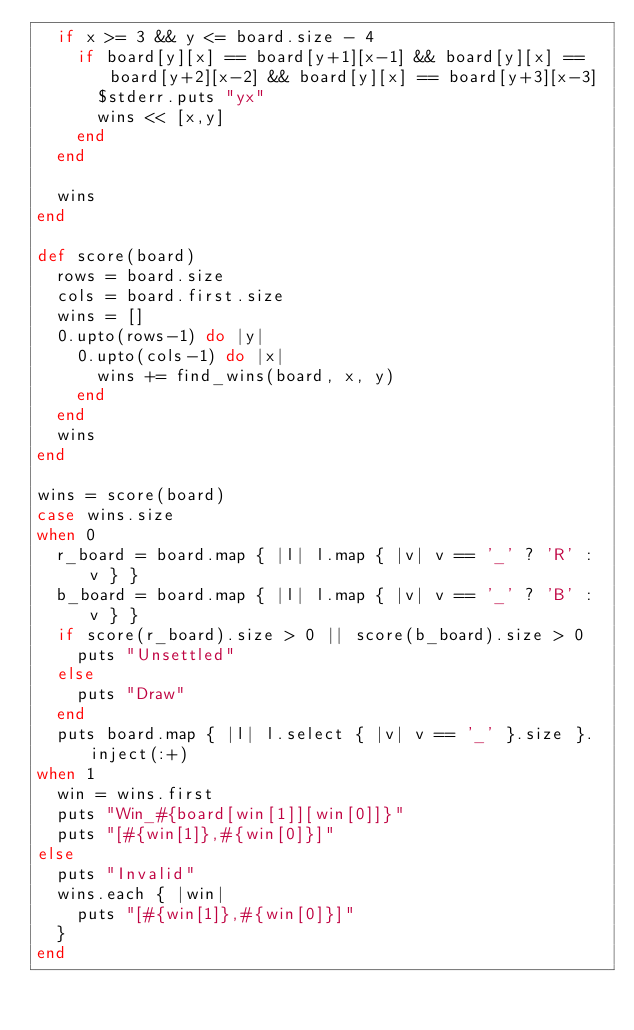Convert code to text. <code><loc_0><loc_0><loc_500><loc_500><_Ruby_>  if x >= 3 && y <= board.size - 4
    if board[y][x] == board[y+1][x-1] && board[y][x] == board[y+2][x-2] && board[y][x] == board[y+3][x-3]
      $stderr.puts "yx"
      wins << [x,y]
    end
  end
  
  wins
end

def score(board)
  rows = board.size
  cols = board.first.size
  wins = []
  0.upto(rows-1) do |y|
    0.upto(cols-1) do |x|
      wins += find_wins(board, x, y)
    end
  end
  wins
end

wins = score(board)
case wins.size
when 0
  r_board = board.map { |l| l.map { |v| v == '_' ? 'R' : v } }
  b_board = board.map { |l| l.map { |v| v == '_' ? 'B' : v } }
  if score(r_board).size > 0 || score(b_board).size > 0
    puts "Unsettled"
  else
    puts "Draw"
  end
  puts board.map { |l| l.select { |v| v == '_' }.size }.inject(:+)
when 1
  win = wins.first
  puts "Win_#{board[win[1]][win[0]]}"
  puts "[#{win[1]},#{win[0]}]"
else
  puts "Invalid"
  wins.each { |win|
    puts "[#{win[1]},#{win[0]}]"
  }
end
</code> 